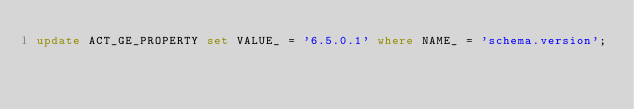Convert code to text. <code><loc_0><loc_0><loc_500><loc_500><_SQL_>update ACT_GE_PROPERTY set VALUE_ = '6.5.0.1' where NAME_ = 'schema.version';

</code> 